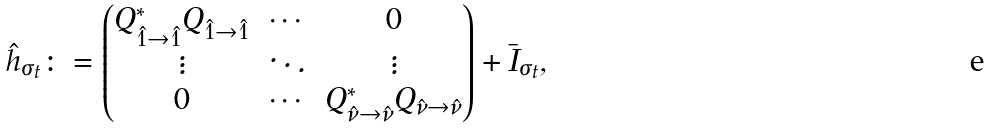<formula> <loc_0><loc_0><loc_500><loc_500>\hat { h } _ { \sigma _ { t } } \colon = \begin{pmatrix} Q ^ { * } _ { \hat { 1 } \to \hat { 1 } } Q _ { \hat { 1 } \to \hat { 1 } } & \cdots & 0 \\ \vdots & \ddots & \vdots \\ 0 & \cdots & Q ^ { * } _ { { \hat { \nu } } \to \hat { \nu } } Q _ { \hat { \nu } \to { \hat { \nu } } } \end{pmatrix} + \bar { I } _ { \sigma _ { t } } ,</formula> 